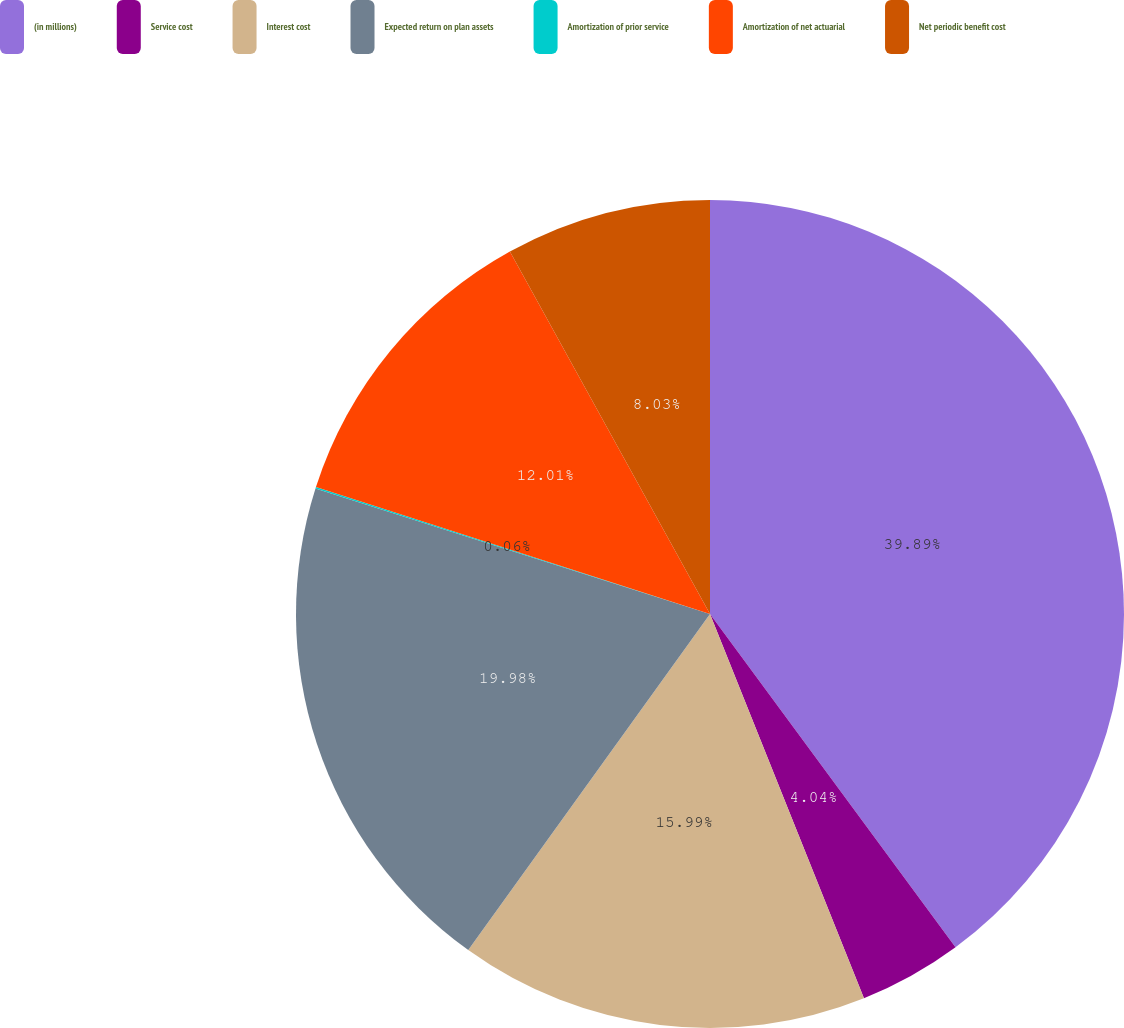Convert chart. <chart><loc_0><loc_0><loc_500><loc_500><pie_chart><fcel>(in millions)<fcel>Service cost<fcel>Interest cost<fcel>Expected return on plan assets<fcel>Amortization of prior service<fcel>Amortization of net actuarial<fcel>Net periodic benefit cost<nl><fcel>39.9%<fcel>4.04%<fcel>15.99%<fcel>19.98%<fcel>0.06%<fcel>12.01%<fcel>8.03%<nl></chart> 